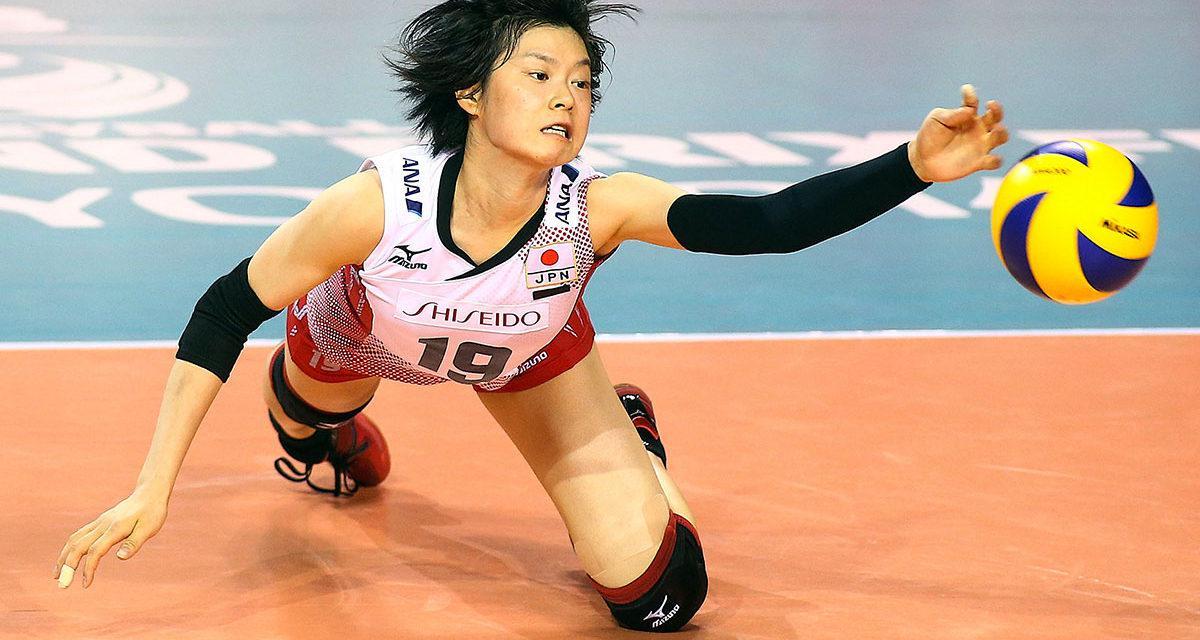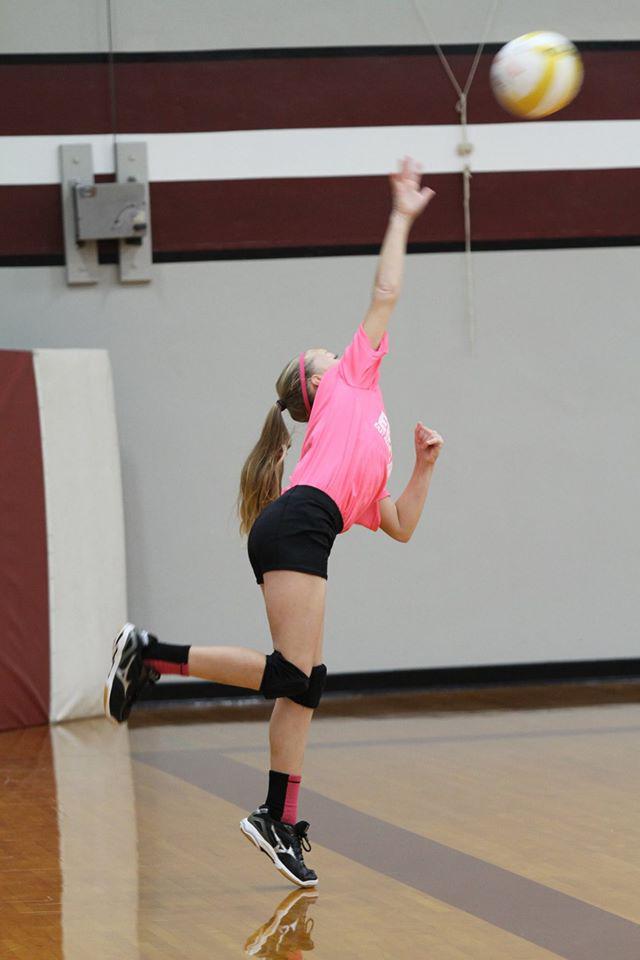The first image is the image on the left, the second image is the image on the right. Evaluate the accuracy of this statement regarding the images: "The left and right image contains a total of two women playing volleyball.". Is it true? Answer yes or no. Yes. The first image is the image on the left, the second image is the image on the right. Given the left and right images, does the statement "One image features an upright girl reaching toward a volleyball with at least one foot off the ground, and the other image features a girl on at least one knee with a volleyball in front of one arm." hold true? Answer yes or no. Yes. 